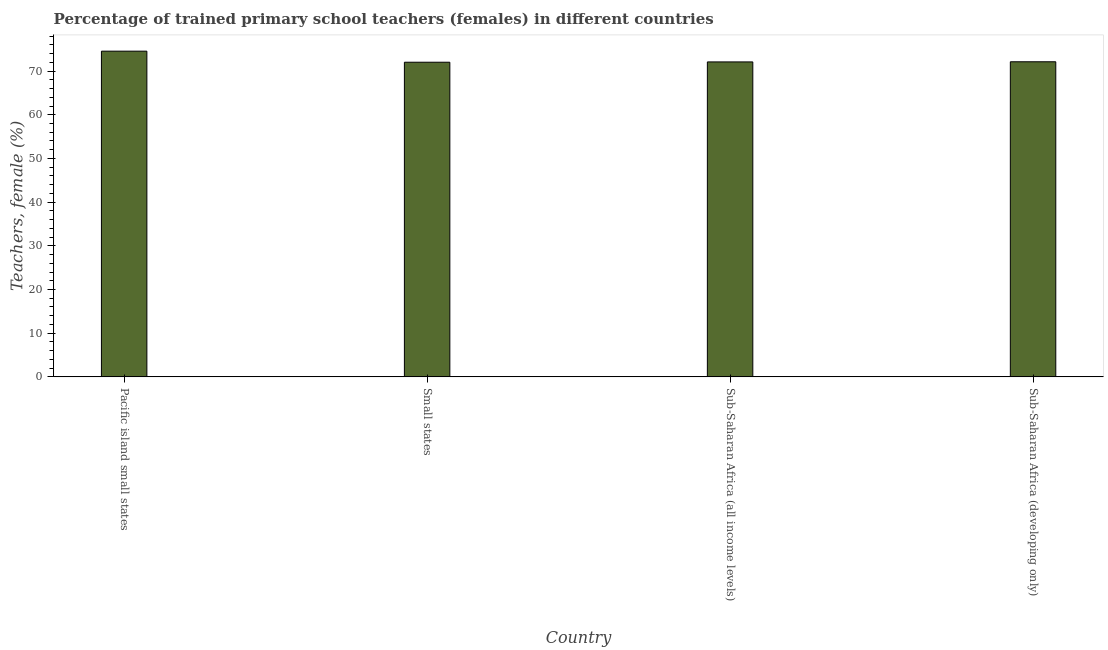Does the graph contain grids?
Provide a succinct answer. No. What is the title of the graph?
Ensure brevity in your answer.  Percentage of trained primary school teachers (females) in different countries. What is the label or title of the X-axis?
Keep it short and to the point. Country. What is the label or title of the Y-axis?
Offer a terse response. Teachers, female (%). What is the percentage of trained female teachers in Sub-Saharan Africa (developing only)?
Keep it short and to the point. 72.13. Across all countries, what is the maximum percentage of trained female teachers?
Offer a very short reply. 74.55. Across all countries, what is the minimum percentage of trained female teachers?
Ensure brevity in your answer.  72.02. In which country was the percentage of trained female teachers maximum?
Keep it short and to the point. Pacific island small states. In which country was the percentage of trained female teachers minimum?
Offer a very short reply. Small states. What is the sum of the percentage of trained female teachers?
Offer a terse response. 290.79. What is the difference between the percentage of trained female teachers in Pacific island small states and Sub-Saharan Africa (all income levels)?
Keep it short and to the point. 2.46. What is the average percentage of trained female teachers per country?
Make the answer very short. 72.7. What is the median percentage of trained female teachers?
Offer a terse response. 72.11. What is the ratio of the percentage of trained female teachers in Pacific island small states to that in Sub-Saharan Africa (developing only)?
Ensure brevity in your answer.  1.03. Is the percentage of trained female teachers in Small states less than that in Sub-Saharan Africa (developing only)?
Your answer should be compact. Yes. What is the difference between the highest and the second highest percentage of trained female teachers?
Your answer should be compact. 2.43. What is the difference between the highest and the lowest percentage of trained female teachers?
Ensure brevity in your answer.  2.53. In how many countries, is the percentage of trained female teachers greater than the average percentage of trained female teachers taken over all countries?
Offer a terse response. 1. Are all the bars in the graph horizontal?
Keep it short and to the point. No. What is the Teachers, female (%) in Pacific island small states?
Ensure brevity in your answer.  74.55. What is the Teachers, female (%) of Small states?
Offer a terse response. 72.02. What is the Teachers, female (%) in Sub-Saharan Africa (all income levels)?
Offer a very short reply. 72.09. What is the Teachers, female (%) in Sub-Saharan Africa (developing only)?
Ensure brevity in your answer.  72.13. What is the difference between the Teachers, female (%) in Pacific island small states and Small states?
Provide a succinct answer. 2.53. What is the difference between the Teachers, female (%) in Pacific island small states and Sub-Saharan Africa (all income levels)?
Provide a short and direct response. 2.46. What is the difference between the Teachers, female (%) in Pacific island small states and Sub-Saharan Africa (developing only)?
Give a very brief answer. 2.43. What is the difference between the Teachers, female (%) in Small states and Sub-Saharan Africa (all income levels)?
Provide a succinct answer. -0.07. What is the difference between the Teachers, female (%) in Small states and Sub-Saharan Africa (developing only)?
Ensure brevity in your answer.  -0.1. What is the difference between the Teachers, female (%) in Sub-Saharan Africa (all income levels) and Sub-Saharan Africa (developing only)?
Ensure brevity in your answer.  -0.03. What is the ratio of the Teachers, female (%) in Pacific island small states to that in Small states?
Your answer should be compact. 1.03. What is the ratio of the Teachers, female (%) in Pacific island small states to that in Sub-Saharan Africa (all income levels)?
Offer a terse response. 1.03. What is the ratio of the Teachers, female (%) in Pacific island small states to that in Sub-Saharan Africa (developing only)?
Ensure brevity in your answer.  1.03. 